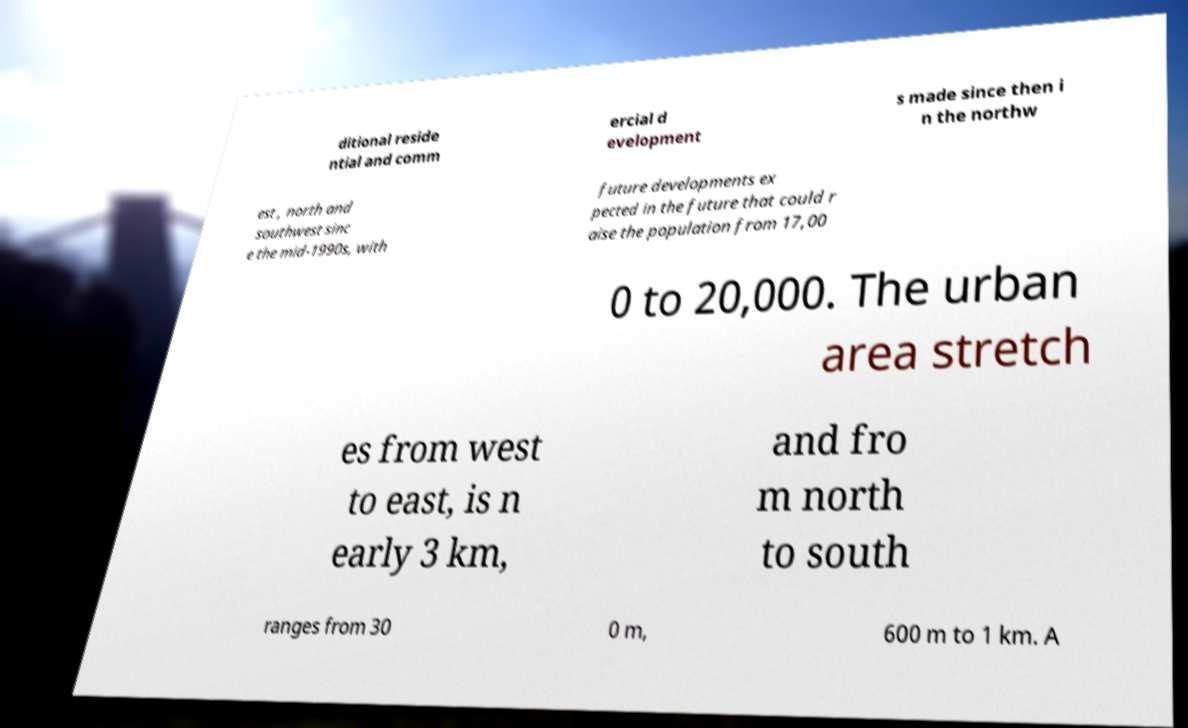Can you accurately transcribe the text from the provided image for me? ditional reside ntial and comm ercial d evelopment s made since then i n the northw est , north and southwest sinc e the mid-1990s, with future developments ex pected in the future that could r aise the population from 17,00 0 to 20,000. The urban area stretch es from west to east, is n early 3 km, and fro m north to south ranges from 30 0 m, 600 m to 1 km. A 